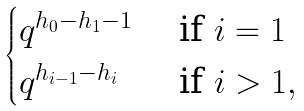<formula> <loc_0><loc_0><loc_500><loc_500>\begin{cases} q ^ { h _ { 0 } - h _ { 1 } - 1 } & \text { if } i = 1 \\ q ^ { h _ { i - 1 } - h _ { i } } & \text { if } i > 1 , \end{cases}</formula> 